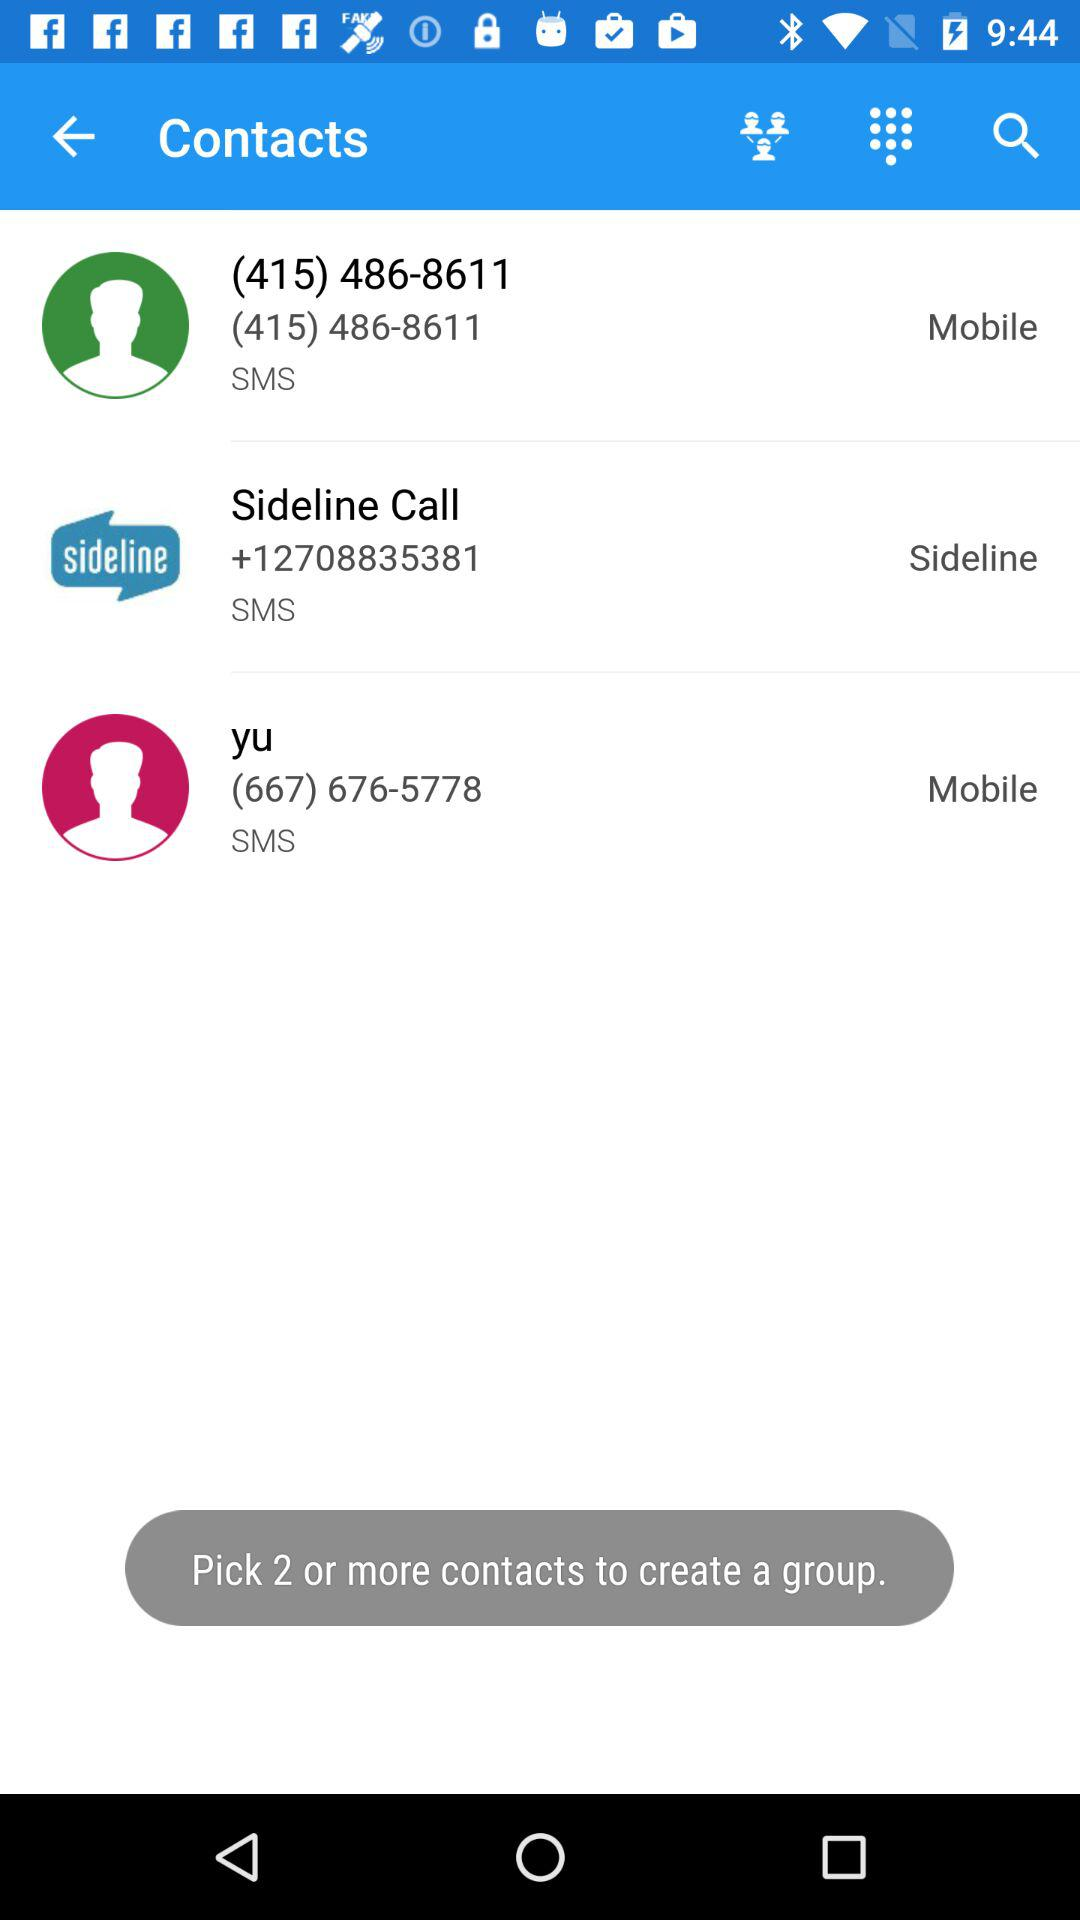How many contacts can be picked? You can pick two or more contacts. 